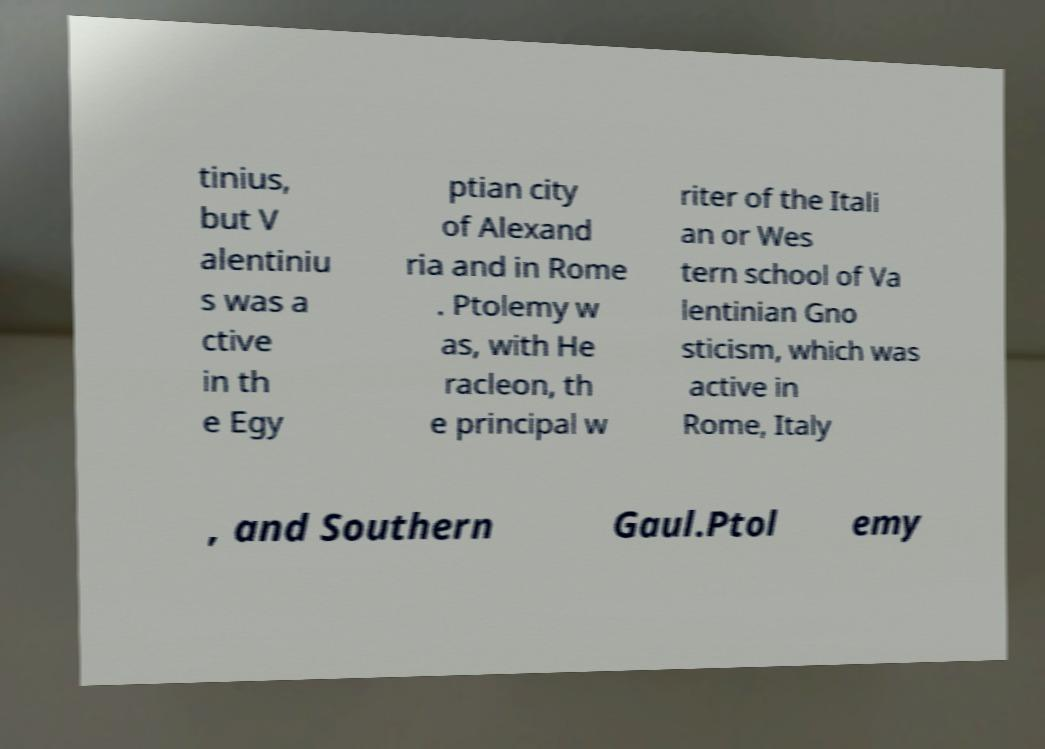Please identify and transcribe the text found in this image. tinius, but V alentiniu s was a ctive in th e Egy ptian city of Alexand ria and in Rome . Ptolemy w as, with He racleon, th e principal w riter of the Itali an or Wes tern school of Va lentinian Gno sticism, which was active in Rome, Italy , and Southern Gaul.Ptol emy 